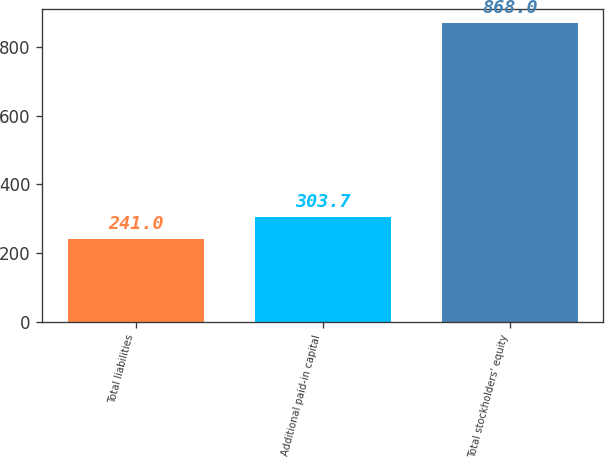Convert chart to OTSL. <chart><loc_0><loc_0><loc_500><loc_500><bar_chart><fcel>Total liabilities<fcel>Additional paid-in capital<fcel>Total stockholders' equity<nl><fcel>241<fcel>303.7<fcel>868<nl></chart> 